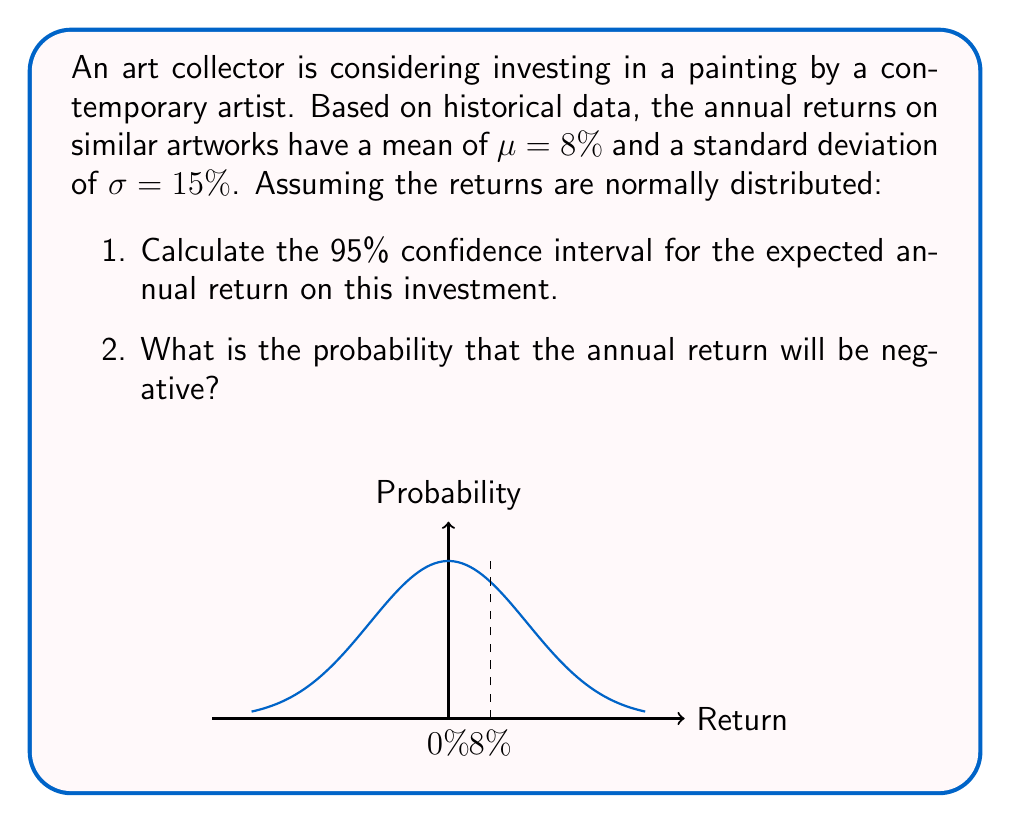Solve this math problem. Let's approach this problem step-by-step:

1. Given information:
   - Mean annual return (μ) = 8%
   - Standard deviation (σ) = 15%
   - Assuming normal distribution
   - Confidence level = 95%

2. For a 95% confidence interval, we use a z-score of 1.96 (from the standard normal distribution table).

3. The formula for confidence interval is:
   $$ CI = \mu \pm (z \times \frac{\sigma}{\sqrt{n}}) $$
   Where n is the sample size. Since we're dealing with the population parameters, we can consider n to be very large, so $\frac{\sigma}{\sqrt{n}}$ approaches 0.

4. Therefore, our 95% confidence interval is:
   $$ CI = 8\% \pm (1.96 \times 15\%) $$
   $$ CI = 8\% \pm 29.4\% $$
   $$ CI = (-21.4\%, 37.4\%) $$

5. To find the probability of a negative return, we need to calculate the z-score for 0% return:
   $$ z = \frac{x - \mu}{\sigma} = \frac{0\% - 8\%}{15\%} = -0.533 $$

6. Using a standard normal distribution table or calculator, we find that the area to the left of z = -0.533 is approximately 0.2971.

Therefore, the probability of a negative return is 0.2971 or 29.71%.
Answer: 95% CI: (-21.4%, 37.4%); Probability of negative return: 29.71% 